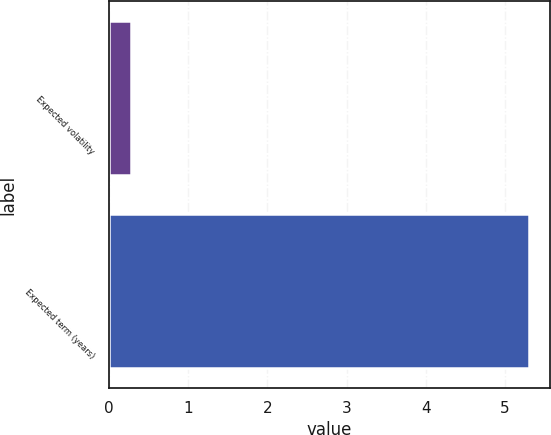Convert chart. <chart><loc_0><loc_0><loc_500><loc_500><bar_chart><fcel>Expected volatility<fcel>Expected term (years)<nl><fcel>0.28<fcel>5.3<nl></chart> 